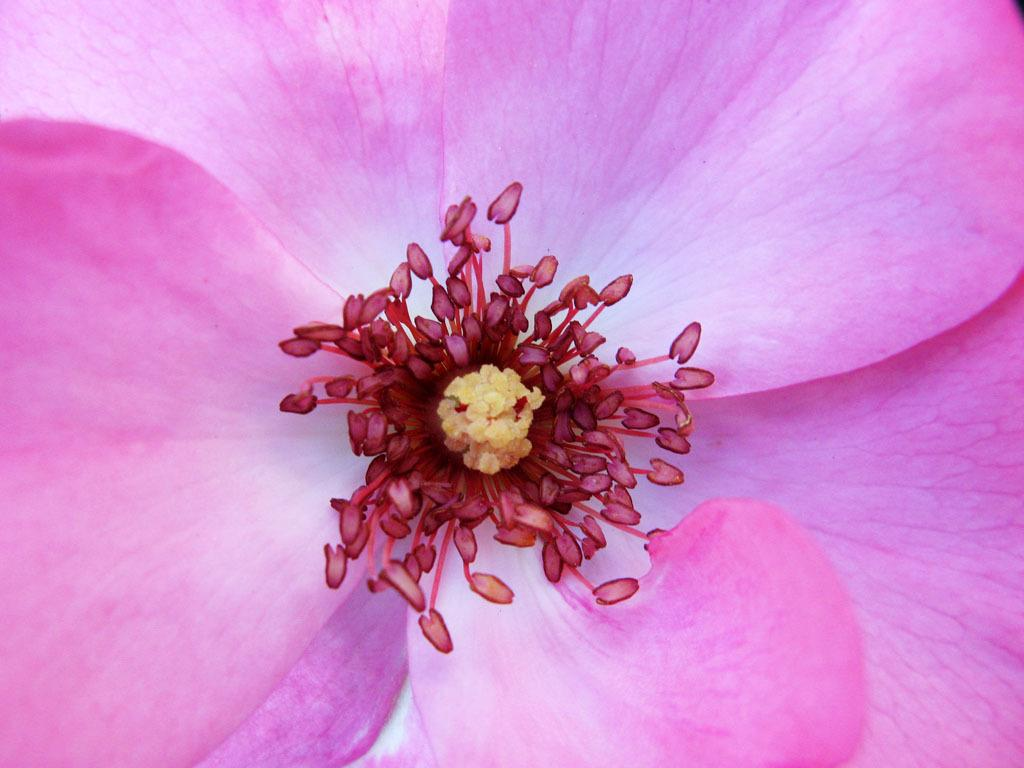What is the main subject of the image? There is a flower in the image. Can you describe the color of the flower? The flower is pink in color. How many owls are sitting on the flower in the image? There are no owls present in the image; it only features a pink flower. 